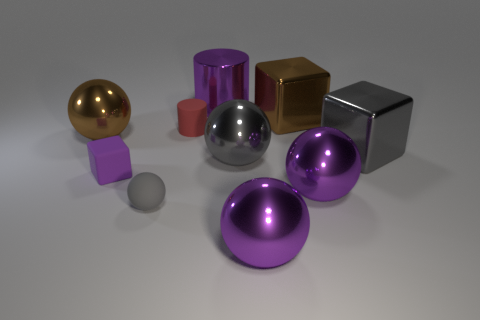Do the shiny cylinder and the small matte cube have the same color?
Offer a terse response. Yes. What material is the sphere that is the same size as the purple matte cube?
Your answer should be compact. Rubber. What number of other things are the same color as the tiny rubber cube?
Give a very brief answer. 3. There is a block in front of the big gray ball; is it the same color as the large cylinder?
Offer a terse response. Yes. Are the gray ball behind the purple cube and the small gray sphere made of the same material?
Your answer should be compact. No. What number of purple rubber cubes are to the left of the purple object to the left of the big purple thing behind the big gray metal ball?
Make the answer very short. 0. Does the purple metal thing that is behind the red cylinder have the same shape as the purple matte object?
Your answer should be very brief. No. Is there a big brown shiny block left of the big brown block behind the tiny purple cube?
Ensure brevity in your answer.  No. What number of gray metal things are there?
Provide a succinct answer. 2. There is a thing that is both behind the brown ball and to the left of the metallic cylinder; what is its color?
Offer a terse response. Red. 